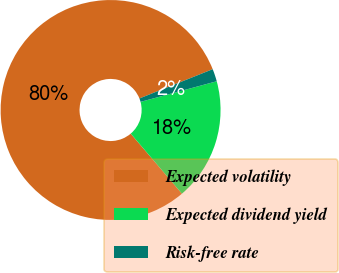Convert chart to OTSL. <chart><loc_0><loc_0><loc_500><loc_500><pie_chart><fcel>Expected volatility<fcel>Expected dividend yield<fcel>Risk-free rate<nl><fcel>80.18%<fcel>17.97%<fcel>1.84%<nl></chart> 